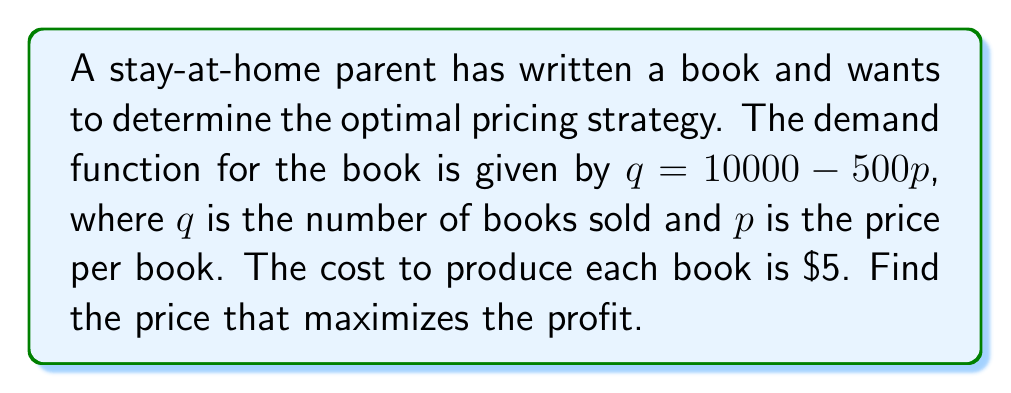Help me with this question. 1) First, let's define the profit function. Profit is revenue minus cost:
   $$ \text{Profit} = \text{Revenue} - \text{Cost} $$

2) Revenue is price times quantity: $pq$
   Cost is $5 per book times quantity: $5q$
   So, our profit function is:
   $$ \text{Profit} = pq - 5q $$

3) Substitute the demand function $q = 10000 - 500p$ into the profit function:
   $$ \text{Profit} = p(10000 - 500p) - 5(10000 - 500p) $$

4) Expand this expression:
   $$ \text{Profit} = 10000p - 500p^2 - 50000 + 2500p $$
   $$ \text{Profit} = -500p^2 + 12500p - 50000 $$

5) To find the maximum profit, we need to find where the derivative of the profit function equals zero:
   $$ \frac{d}{dp}(\text{Profit}) = -1000p + 12500 = 0 $$

6) Solve this equation:
   $$ -1000p + 12500 = 0 $$
   $$ -1000p = -12500 $$
   $$ p = 12.5 $$

7) To confirm this is a maximum (not a minimum), check the second derivative:
   $$ \frac{d^2}{dp^2}(\text{Profit}) = -1000 $$
   This is negative, confirming we've found a maximum.
Answer: $12.50 